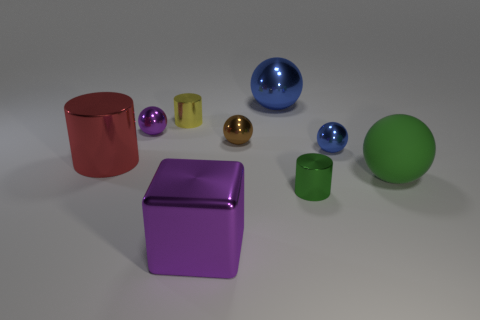What can you infer about the light source in this scene? The shadows cast by the objects and the highlights on the surfaces suggest that the light source is coming from the upper left direction, possibly a single directional light source such as a softbox or a window. Can you describe how the light is affecting the colors of the objects? The light source is enhancing the vividness of the colors and creating contrast. It brings out the shine on the reflective surfaces and adds depth to the objects by creating shadows on the sides opposite the light, which helps to differentiate each object's form and material. 